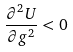Convert formula to latex. <formula><loc_0><loc_0><loc_500><loc_500>\frac { \partial ^ { 2 } U } { \partial g ^ { 2 } } < 0</formula> 